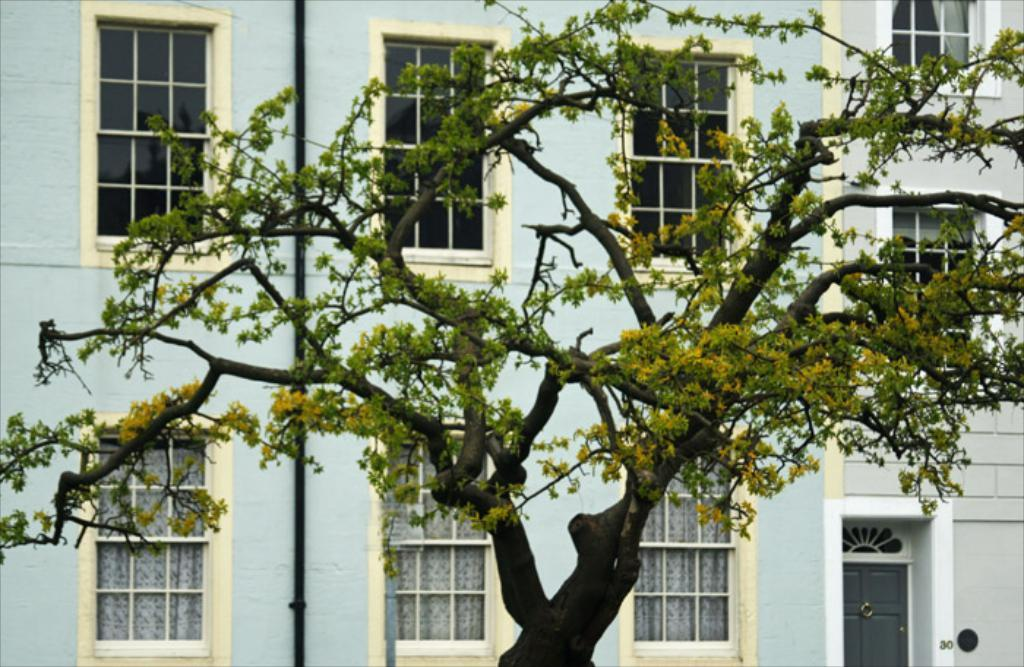What type of natural element is present in the picture? There is a tree in the picture. What type of man-made structure is present in the picture? There is a building in the picture. What features can be seen on the building? The building has windows, doors, and a pipe. What type of border is depicted around the tree in the image? There is no border depicted around the tree in the image; it is a natural element without any man-made borders. 